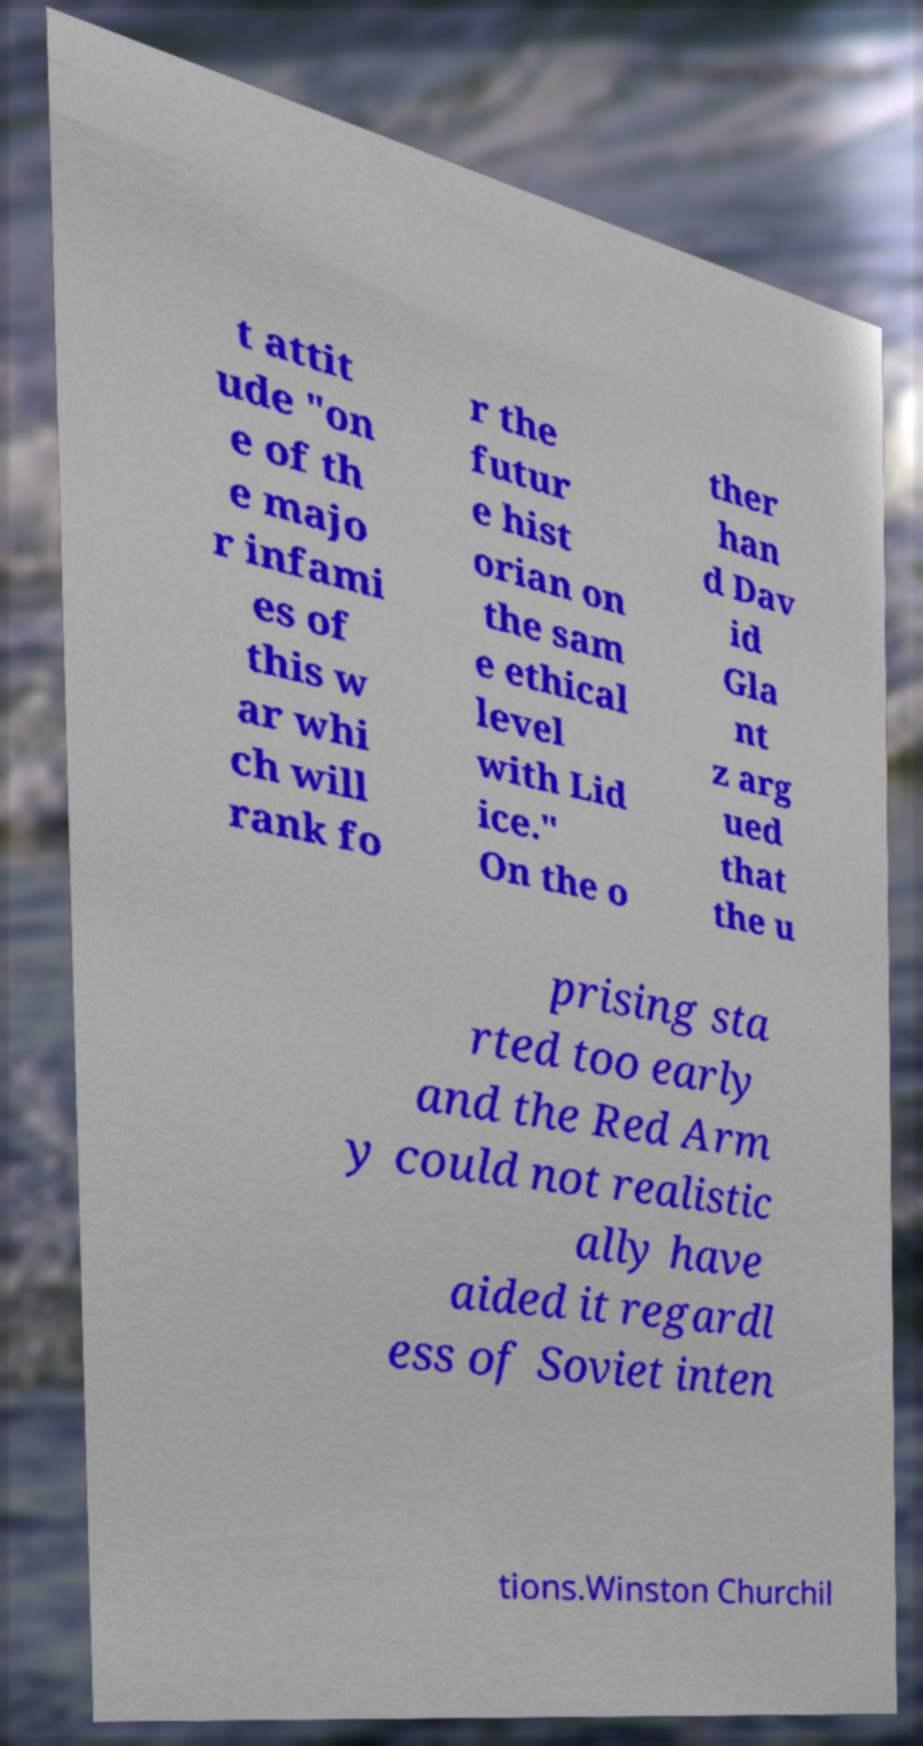Could you extract and type out the text from this image? t attit ude "on e of th e majo r infami es of this w ar whi ch will rank fo r the futur e hist orian on the sam e ethical level with Lid ice." On the o ther han d Dav id Gla nt z arg ued that the u prising sta rted too early and the Red Arm y could not realistic ally have aided it regardl ess of Soviet inten tions.Winston Churchil 